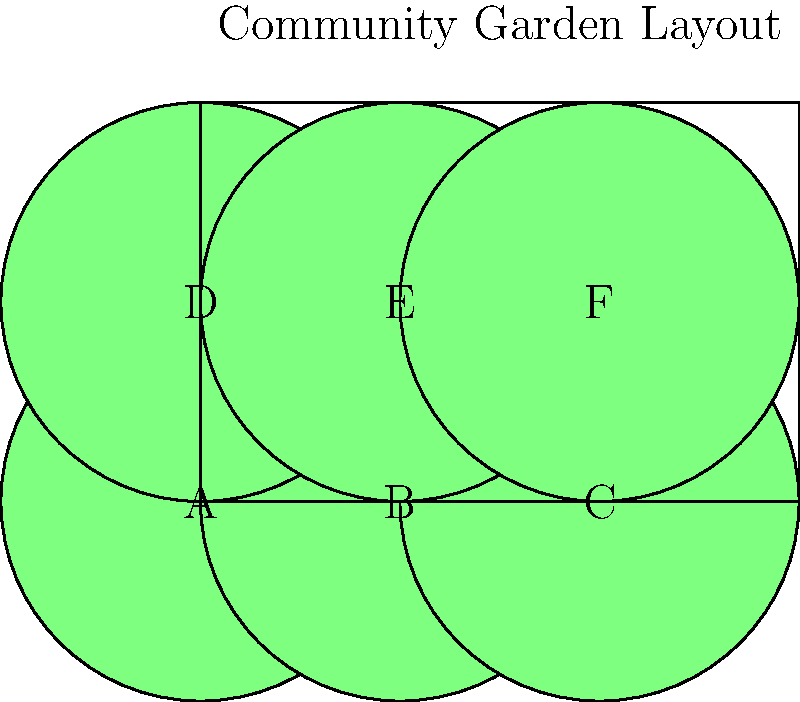In your new village's community garden, there are 6 plots arranged in a 2x3 grid, labeled A through F. How many unique arrangements of these plots are possible if plots A and B must always be adjacent (sharing a side) to each other? Let's approach this step-by-step:

1) First, we consider A and B as a single unit. This leaves us with 5 elements to arrange: the AB unit and plots C, D, E, and F.

2) The number of ways to arrange 5 elements is 5! = 120.

3) However, for each of these arrangements, A and B can be swapped within their unit. This doubles our possibilities.

4) Therefore, the total number of arrangements is:

   $$5! \times 2 = 120 \times 2 = 240$$

5) Let's verify this by considering the possible positions for the AB unit:
   - 3 positions on the top row (AB---, A--B-, ---AB)
   - 3 positions on the bottom row
   - 2 positions vertically (AB above -- or -- above AB)

   This gives us 8 possible positions for AB.

6) For each of these 8 positions, the remaining 4 plots can be arranged in 4! = 24 ways.

7) Thus, we can also calculate: 

   $$8 \times 4! = 8 \times 24 = 192$$

8) But remember, for each arrangement, A and B can be swapped.

   $$192 \times 2 = 384$$

This confirms our original calculation of 240 unique arrangements.
Answer: 240 